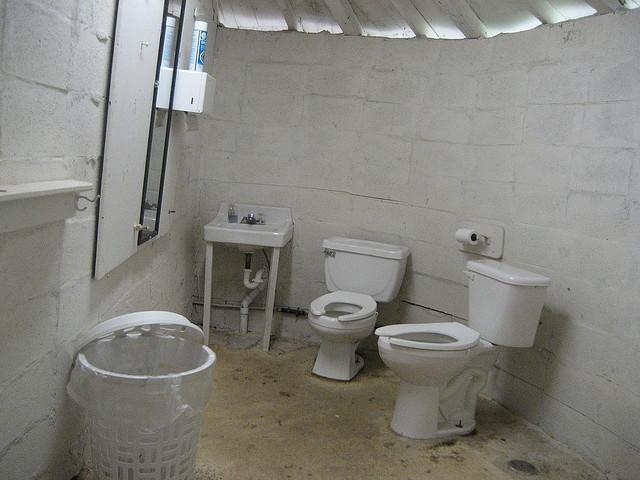How many toilet seats are there?
Give a very brief answer. 2. How many toilets are in the picture?
Give a very brief answer. 2. How many people are sitting?
Give a very brief answer. 0. 